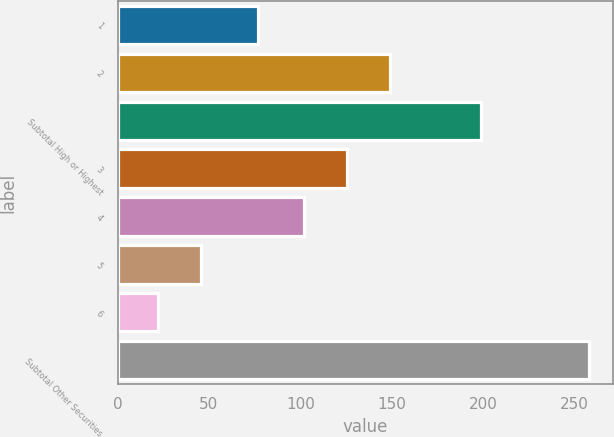Convert chart to OTSL. <chart><loc_0><loc_0><loc_500><loc_500><bar_chart><fcel>1<fcel>2<fcel>Subtotal High or Highest<fcel>3<fcel>4<fcel>5<fcel>6<fcel>Subtotal Other Securities<nl><fcel>77<fcel>149.2<fcel>199<fcel>125.6<fcel>102<fcel>45.6<fcel>22<fcel>258<nl></chart> 